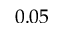<formula> <loc_0><loc_0><loc_500><loc_500>0 . 0 5</formula> 